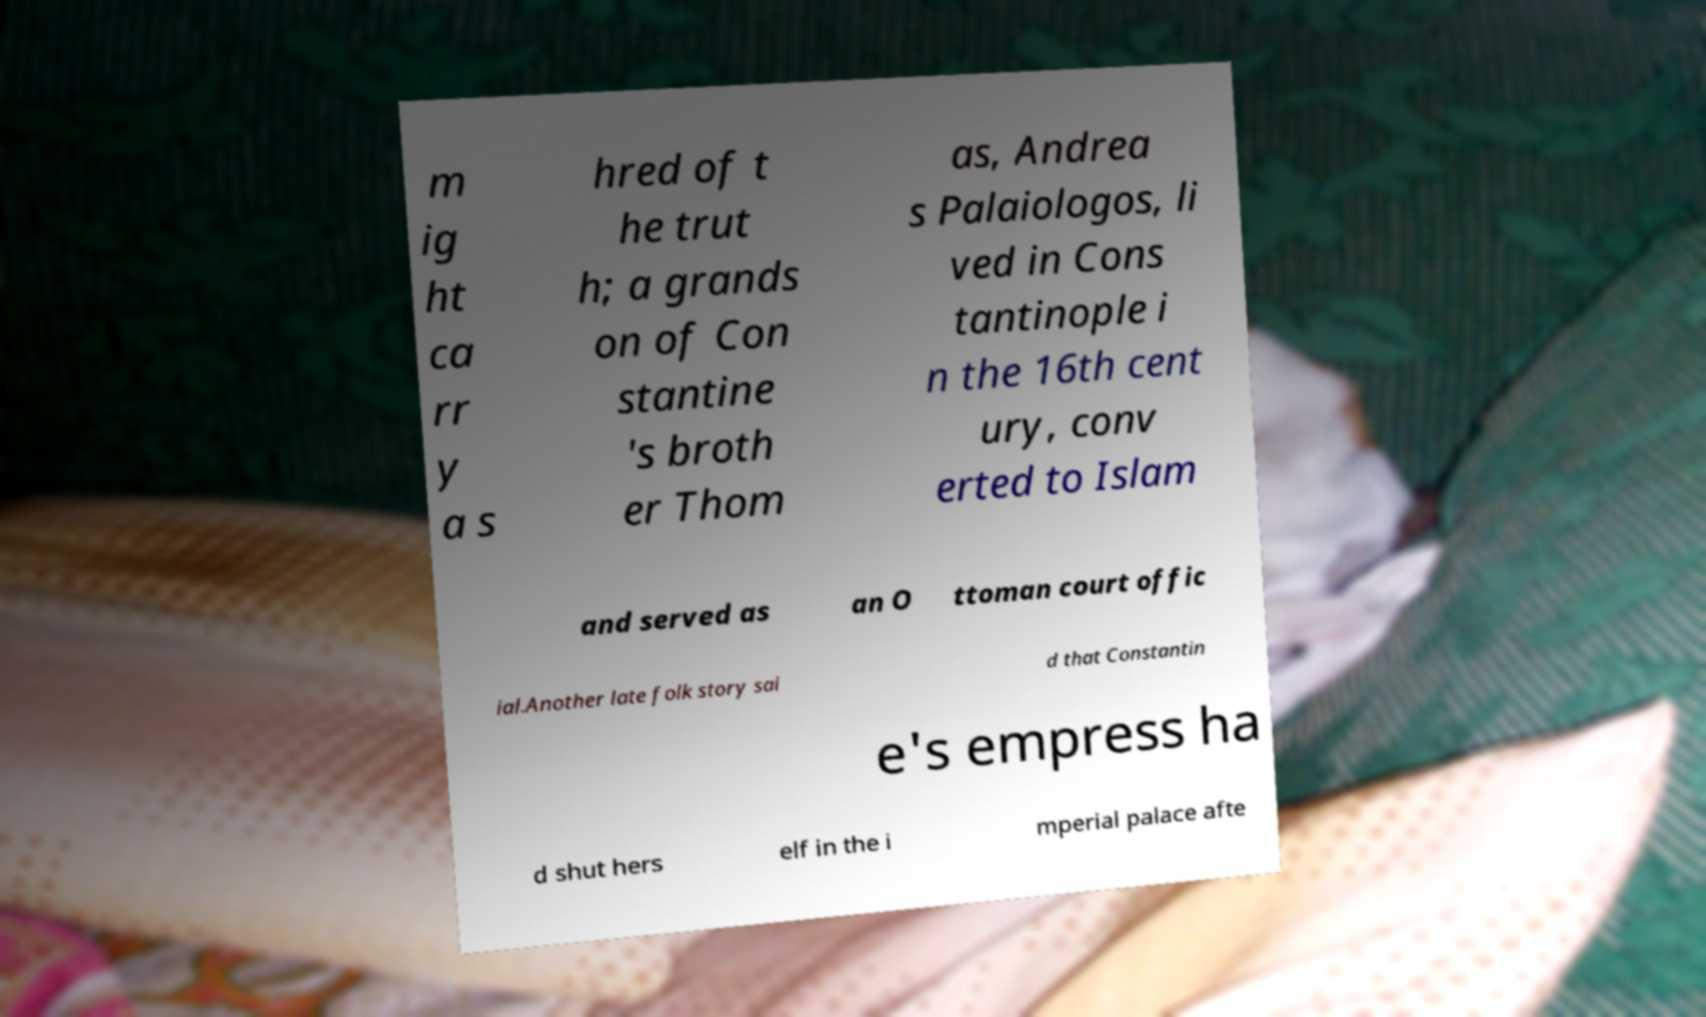What messages or text are displayed in this image? I need them in a readable, typed format. m ig ht ca rr y a s hred of t he trut h; a grands on of Con stantine 's broth er Thom as, Andrea s Palaiologos, li ved in Cons tantinople i n the 16th cent ury, conv erted to Islam and served as an O ttoman court offic ial.Another late folk story sai d that Constantin e's empress ha d shut hers elf in the i mperial palace afte 